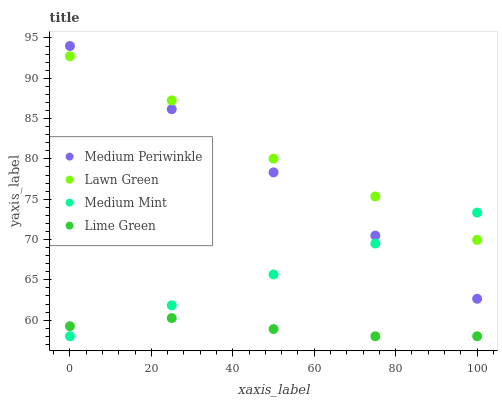Does Lime Green have the minimum area under the curve?
Answer yes or no. Yes. Does Lawn Green have the maximum area under the curve?
Answer yes or no. Yes. Does Medium Periwinkle have the minimum area under the curve?
Answer yes or no. No. Does Medium Periwinkle have the maximum area under the curve?
Answer yes or no. No. Is Medium Mint the smoothest?
Answer yes or no. Yes. Is Lawn Green the roughest?
Answer yes or no. Yes. Is Medium Periwinkle the smoothest?
Answer yes or no. No. Is Medium Periwinkle the roughest?
Answer yes or no. No. Does Medium Mint have the lowest value?
Answer yes or no. Yes. Does Medium Periwinkle have the lowest value?
Answer yes or no. No. Does Medium Periwinkle have the highest value?
Answer yes or no. Yes. Does Lawn Green have the highest value?
Answer yes or no. No. Is Lime Green less than Medium Periwinkle?
Answer yes or no. Yes. Is Medium Periwinkle greater than Lime Green?
Answer yes or no. Yes. Does Lawn Green intersect Medium Mint?
Answer yes or no. Yes. Is Lawn Green less than Medium Mint?
Answer yes or no. No. Is Lawn Green greater than Medium Mint?
Answer yes or no. No. Does Lime Green intersect Medium Periwinkle?
Answer yes or no. No. 